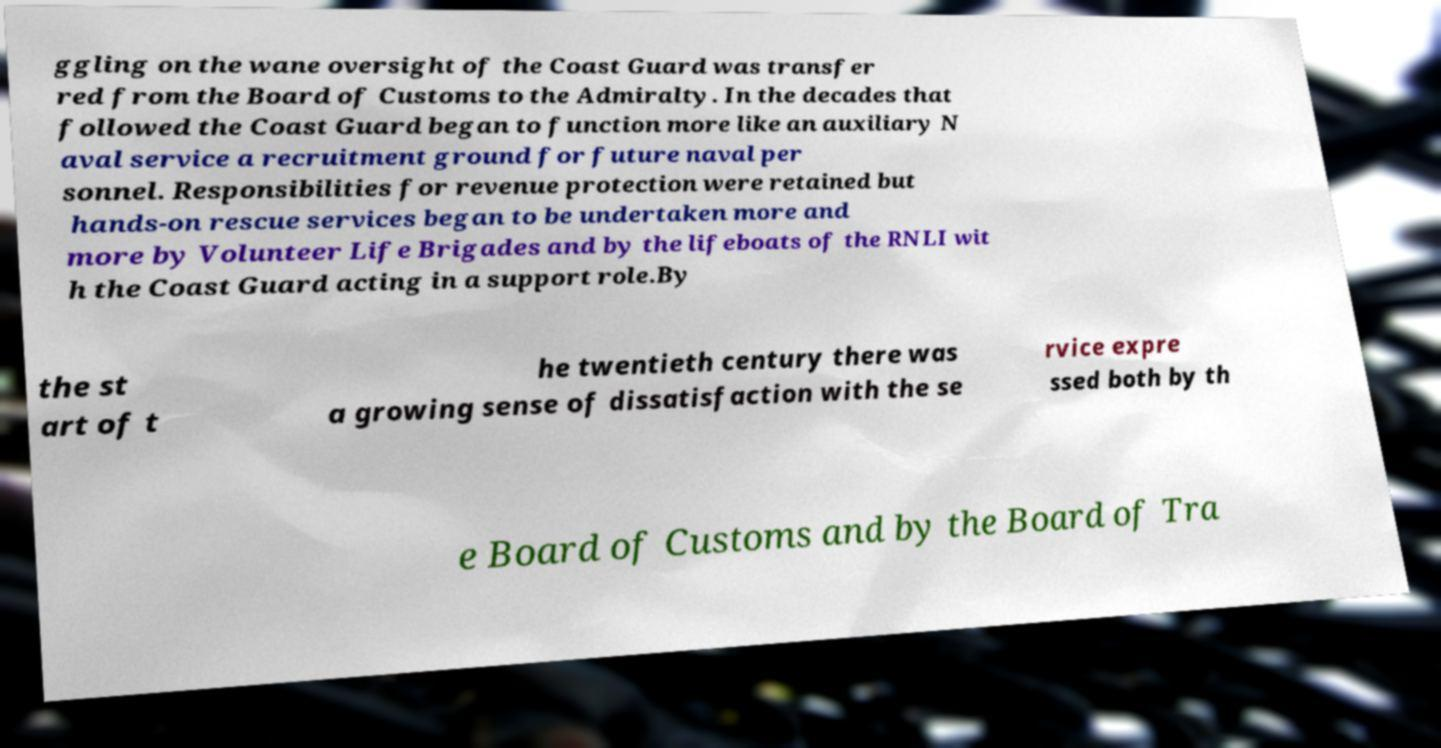What messages or text are displayed in this image? I need them in a readable, typed format. ggling on the wane oversight of the Coast Guard was transfer red from the Board of Customs to the Admiralty. In the decades that followed the Coast Guard began to function more like an auxiliary N aval service a recruitment ground for future naval per sonnel. Responsibilities for revenue protection were retained but hands-on rescue services began to be undertaken more and more by Volunteer Life Brigades and by the lifeboats of the RNLI wit h the Coast Guard acting in a support role.By the st art of t he twentieth century there was a growing sense of dissatisfaction with the se rvice expre ssed both by th e Board of Customs and by the Board of Tra 